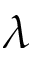<formula> <loc_0><loc_0><loc_500><loc_500>\lambda</formula> 